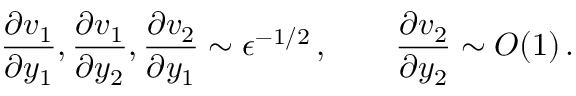<formula> <loc_0><loc_0><loc_500><loc_500>\frac { \partial v _ { 1 } } { \partial y _ { 1 } } , \frac { \partial v _ { 1 } } { \partial y _ { 2 } } , \frac { \partial v _ { 2 } } { \partial y _ { 1 } } \sim \epsilon ^ { - 1 / 2 } \, , \quad \frac { \partial v _ { 2 } } { \partial y _ { 2 } } \sim O ( 1 ) \, .</formula> 